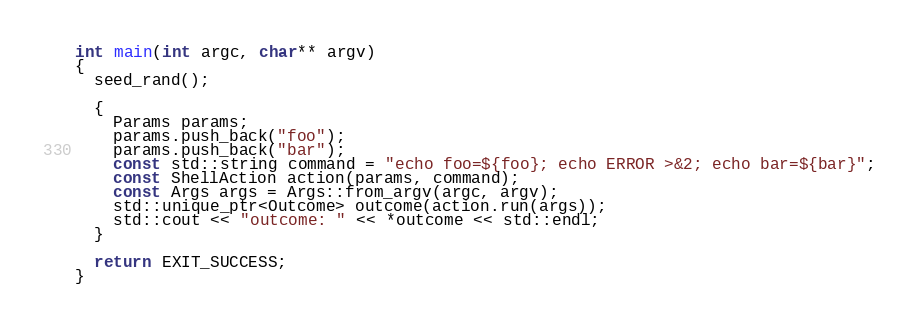Convert code to text. <code><loc_0><loc_0><loc_500><loc_500><_C++_>int main(int argc, char** argv)
{
  seed_rand();

  {
    Params params;
    params.push_back("foo");
    params.push_back("bar");
    const std::string command = "echo foo=${foo}; echo ERROR >&2; echo bar=${bar}";
    const ShellAction action(params, command);
    const Args args = Args::from_argv(argc, argv);
    std::unique_ptr<Outcome> outcome(action.run(args));
    std::cout << "outcome: " << *outcome << std::endl;
  }

  return EXIT_SUCCESS;
}


</code> 